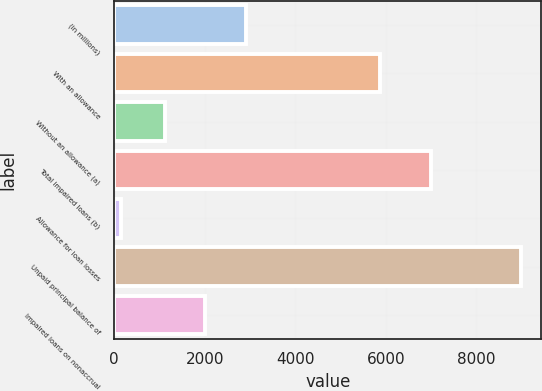Convert chart to OTSL. <chart><loc_0><loc_0><loc_500><loc_500><bar_chart><fcel>(in millions)<fcel>With an allowance<fcel>Without an allowance (a)<fcel>Total impaired loans (b)<fcel>Allowance for loan losses<fcel>Unpaid principal balance of<fcel>Impaired loans on nonaccrual<nl><fcel>2902.2<fcel>5871<fcel>1133<fcel>7004<fcel>144<fcel>8990<fcel>2017.6<nl></chart> 